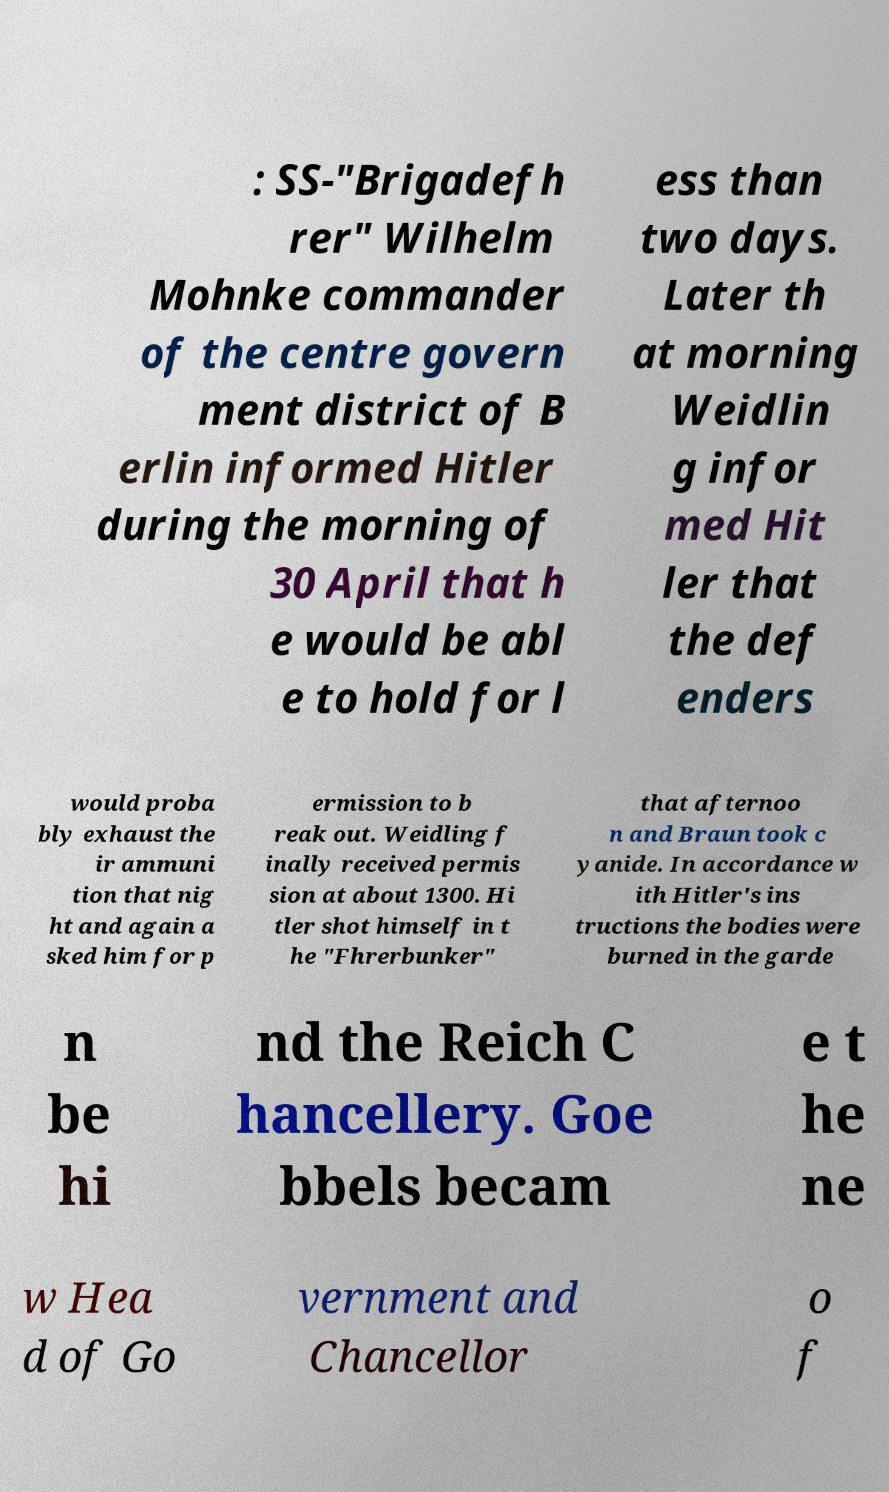What messages or text are displayed in this image? I need them in a readable, typed format. : SS-"Brigadefh rer" Wilhelm Mohnke commander of the centre govern ment district of B erlin informed Hitler during the morning of 30 April that h e would be abl e to hold for l ess than two days. Later th at morning Weidlin g infor med Hit ler that the def enders would proba bly exhaust the ir ammuni tion that nig ht and again a sked him for p ermission to b reak out. Weidling f inally received permis sion at about 1300. Hi tler shot himself in t he "Fhrerbunker" that afternoo n and Braun took c yanide. In accordance w ith Hitler's ins tructions the bodies were burned in the garde n be hi nd the Reich C hancellery. Goe bbels becam e t he ne w Hea d of Go vernment and Chancellor o f 